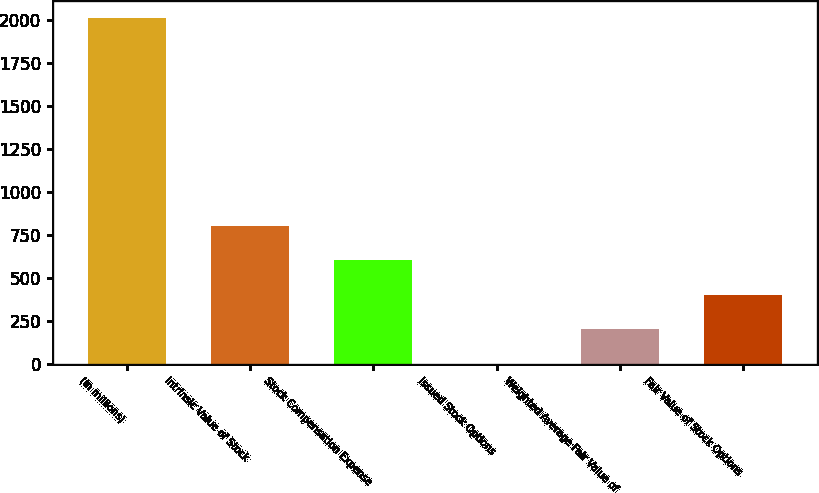Convert chart to OTSL. <chart><loc_0><loc_0><loc_500><loc_500><bar_chart><fcel>(In millions)<fcel>Intrinsic Value of Stock<fcel>Stock Compensation Expense<fcel>Issued Stock Options<fcel>Weighted Average Fair Value of<fcel>Fair Value of Stock Options<nl><fcel>2011<fcel>805.12<fcel>604.14<fcel>1.2<fcel>202.18<fcel>403.16<nl></chart> 